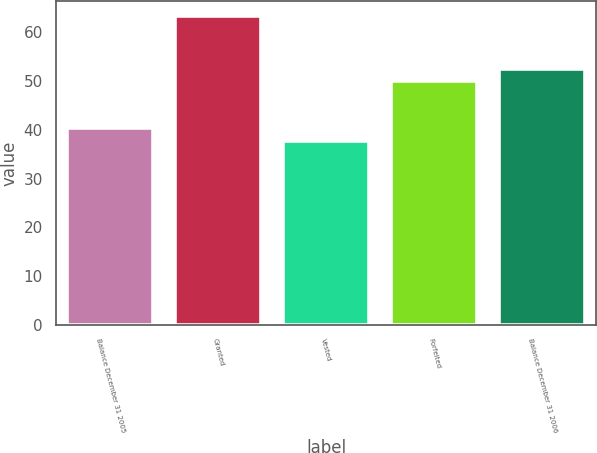Convert chart to OTSL. <chart><loc_0><loc_0><loc_500><loc_500><bar_chart><fcel>Balance December 31 2005<fcel>Granted<fcel>Vested<fcel>Forfeited<fcel>Balance December 31 2006<nl><fcel>40.31<fcel>63.31<fcel>37.76<fcel>50.03<fcel>52.59<nl></chart> 